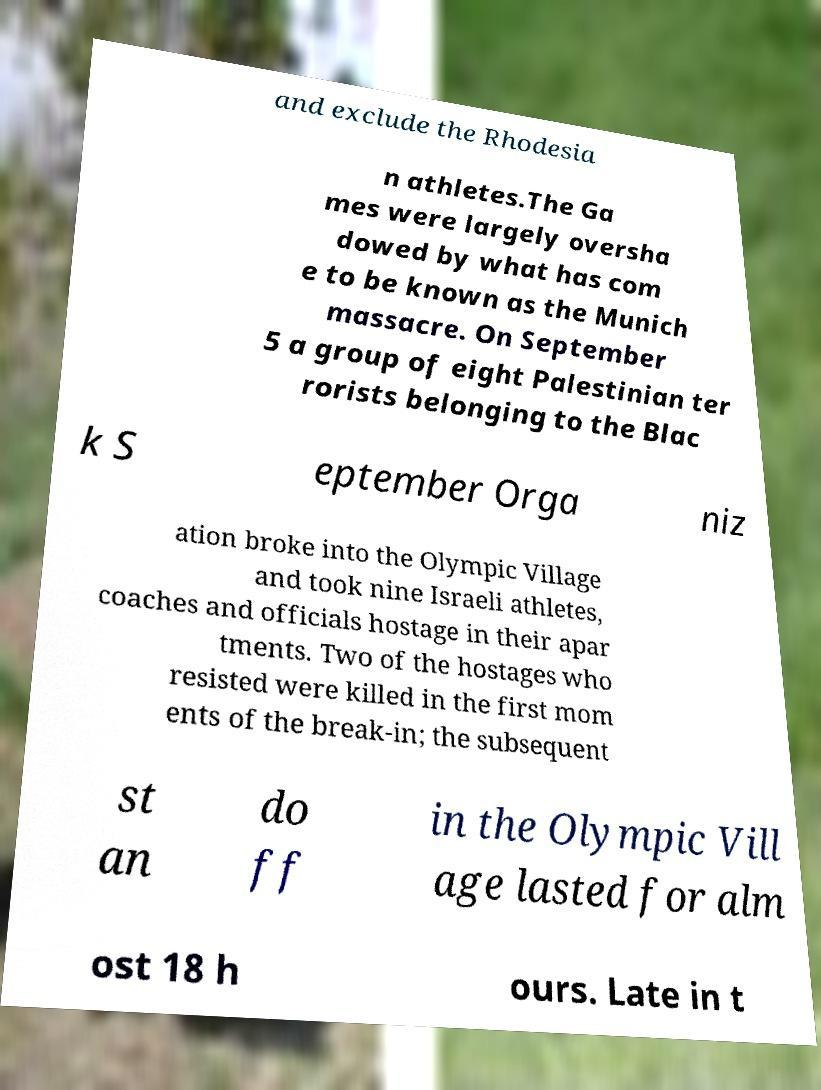I need the written content from this picture converted into text. Can you do that? and exclude the Rhodesia n athletes.The Ga mes were largely oversha dowed by what has com e to be known as the Munich massacre. On September 5 a group of eight Palestinian ter rorists belonging to the Blac k S eptember Orga niz ation broke into the Olympic Village and took nine Israeli athletes, coaches and officials hostage in their apar tments. Two of the hostages who resisted were killed in the first mom ents of the break-in; the subsequent st an do ff in the Olympic Vill age lasted for alm ost 18 h ours. Late in t 